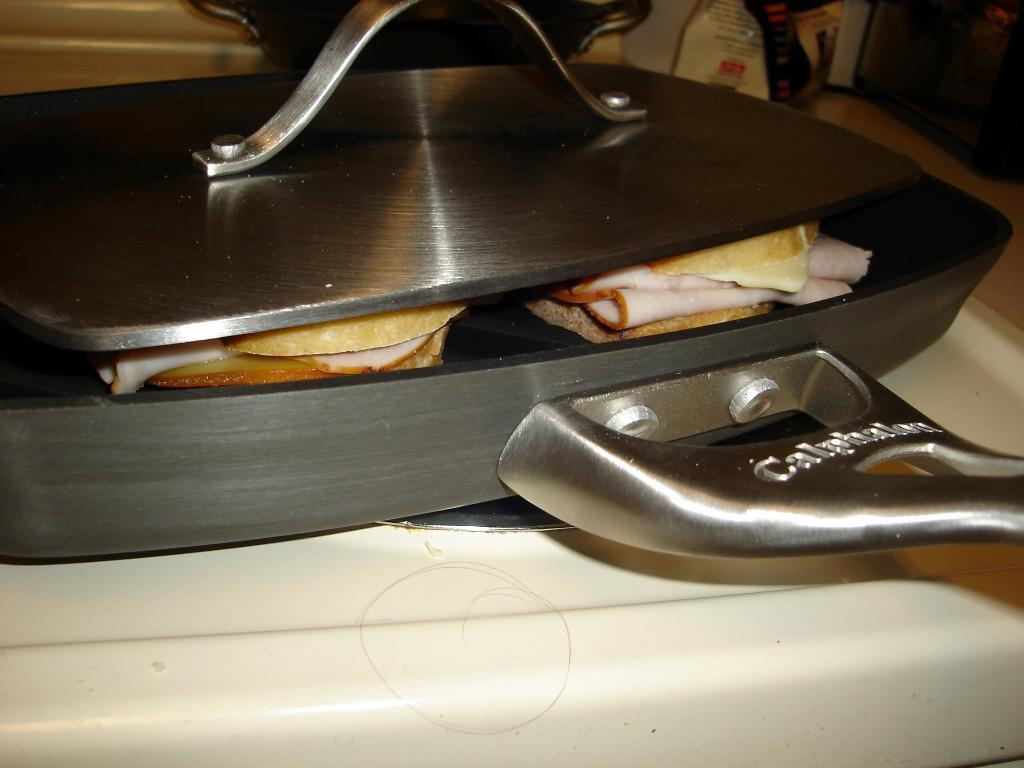What is on the stove in the image? There is a pan on the stove in the image. What is inside the pan? There are two sandwiches in the pan. Is there any covering for the pan? Yes, there is a lid associated with the pan. What type of circle can be seen in the image? There is no circle present in the image. What error is being corrected in the image? There is no error being corrected in the image. 